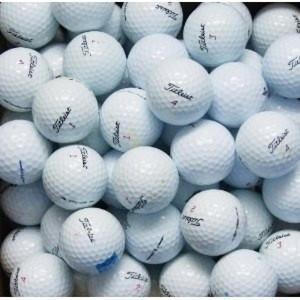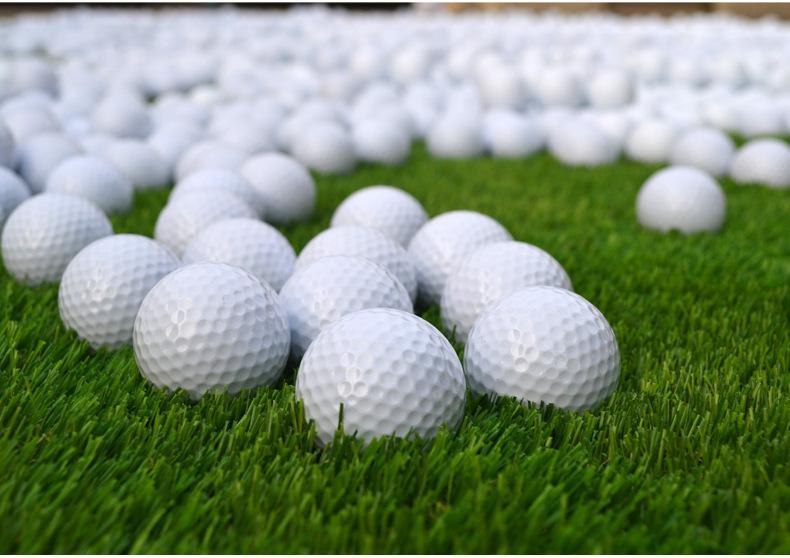The first image is the image on the left, the second image is the image on the right. Assess this claim about the two images: "In at least one image there is a pile of white golf balls and at least one yellow golf ball.". Correct or not? Answer yes or no. No. The first image is the image on the left, the second image is the image on the right. Analyze the images presented: Is the assertion "Some of the balls are not white in one image and all the balls are white in the other image." valid? Answer yes or no. No. 